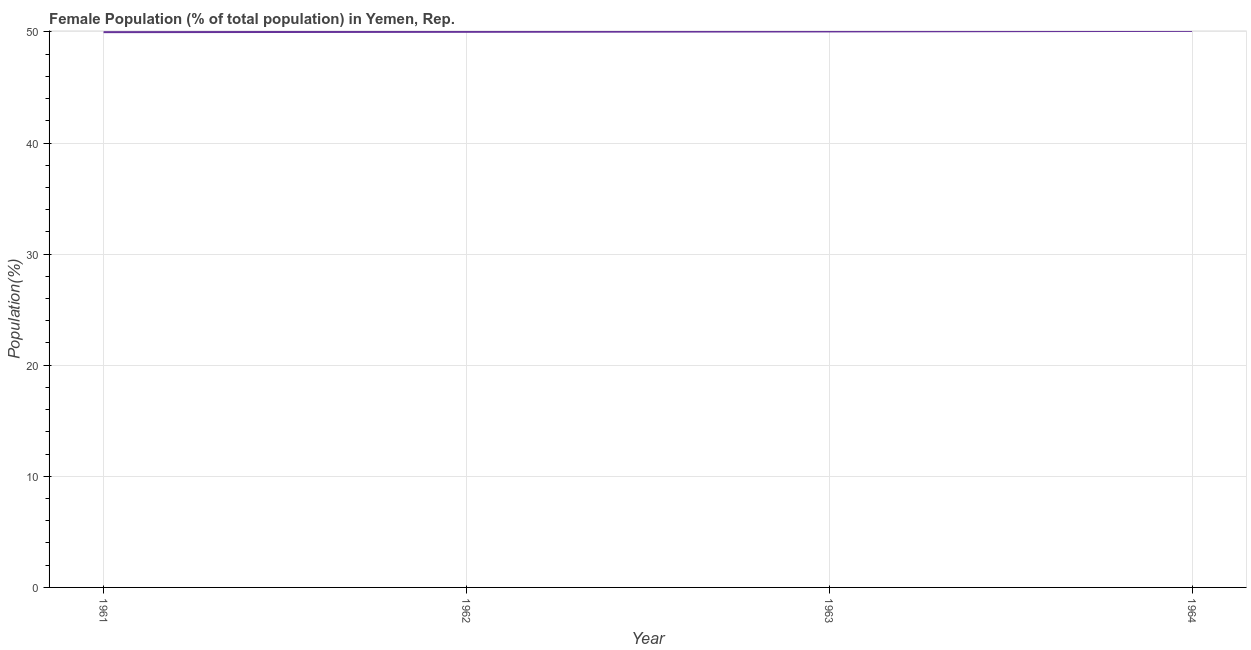What is the female population in 1962?
Keep it short and to the point. 50.01. Across all years, what is the maximum female population?
Provide a succinct answer. 50.09. Across all years, what is the minimum female population?
Your response must be concise. 49.98. In which year was the female population maximum?
Give a very brief answer. 1964. What is the sum of the female population?
Give a very brief answer. 200.12. What is the difference between the female population in 1961 and 1964?
Give a very brief answer. -0.11. What is the average female population per year?
Ensure brevity in your answer.  50.03. What is the median female population?
Ensure brevity in your answer.  50.02. Do a majority of the years between 1964 and 1963 (inclusive) have female population greater than 46 %?
Offer a very short reply. No. What is the ratio of the female population in 1963 to that in 1964?
Make the answer very short. 1. Is the female population in 1962 less than that in 1963?
Make the answer very short. Yes. Is the difference between the female population in 1962 and 1963 greater than the difference between any two years?
Your answer should be compact. No. What is the difference between the highest and the second highest female population?
Make the answer very short. 0.05. What is the difference between the highest and the lowest female population?
Provide a succinct answer. 0.11. In how many years, is the female population greater than the average female population taken over all years?
Offer a terse response. 2. Does the female population monotonically increase over the years?
Offer a terse response. Yes. How many lines are there?
Keep it short and to the point. 1. How many years are there in the graph?
Offer a very short reply. 4. Does the graph contain grids?
Provide a short and direct response. Yes. What is the title of the graph?
Keep it short and to the point. Female Population (% of total population) in Yemen, Rep. What is the label or title of the Y-axis?
Your response must be concise. Population(%). What is the Population(%) in 1961?
Your response must be concise. 49.98. What is the Population(%) in 1962?
Your response must be concise. 50.01. What is the Population(%) of 1963?
Keep it short and to the point. 50.04. What is the Population(%) of 1964?
Offer a terse response. 50.09. What is the difference between the Population(%) in 1961 and 1962?
Give a very brief answer. -0.03. What is the difference between the Population(%) in 1961 and 1963?
Your answer should be compact. -0.07. What is the difference between the Population(%) in 1961 and 1964?
Give a very brief answer. -0.11. What is the difference between the Population(%) in 1962 and 1963?
Your answer should be very brief. -0.04. What is the difference between the Population(%) in 1962 and 1964?
Your answer should be very brief. -0.08. What is the difference between the Population(%) in 1963 and 1964?
Keep it short and to the point. -0.05. What is the ratio of the Population(%) in 1961 to that in 1964?
Provide a short and direct response. 1. What is the ratio of the Population(%) in 1962 to that in 1963?
Provide a succinct answer. 1. What is the ratio of the Population(%) in 1962 to that in 1964?
Provide a succinct answer. 1. What is the ratio of the Population(%) in 1963 to that in 1964?
Make the answer very short. 1. 